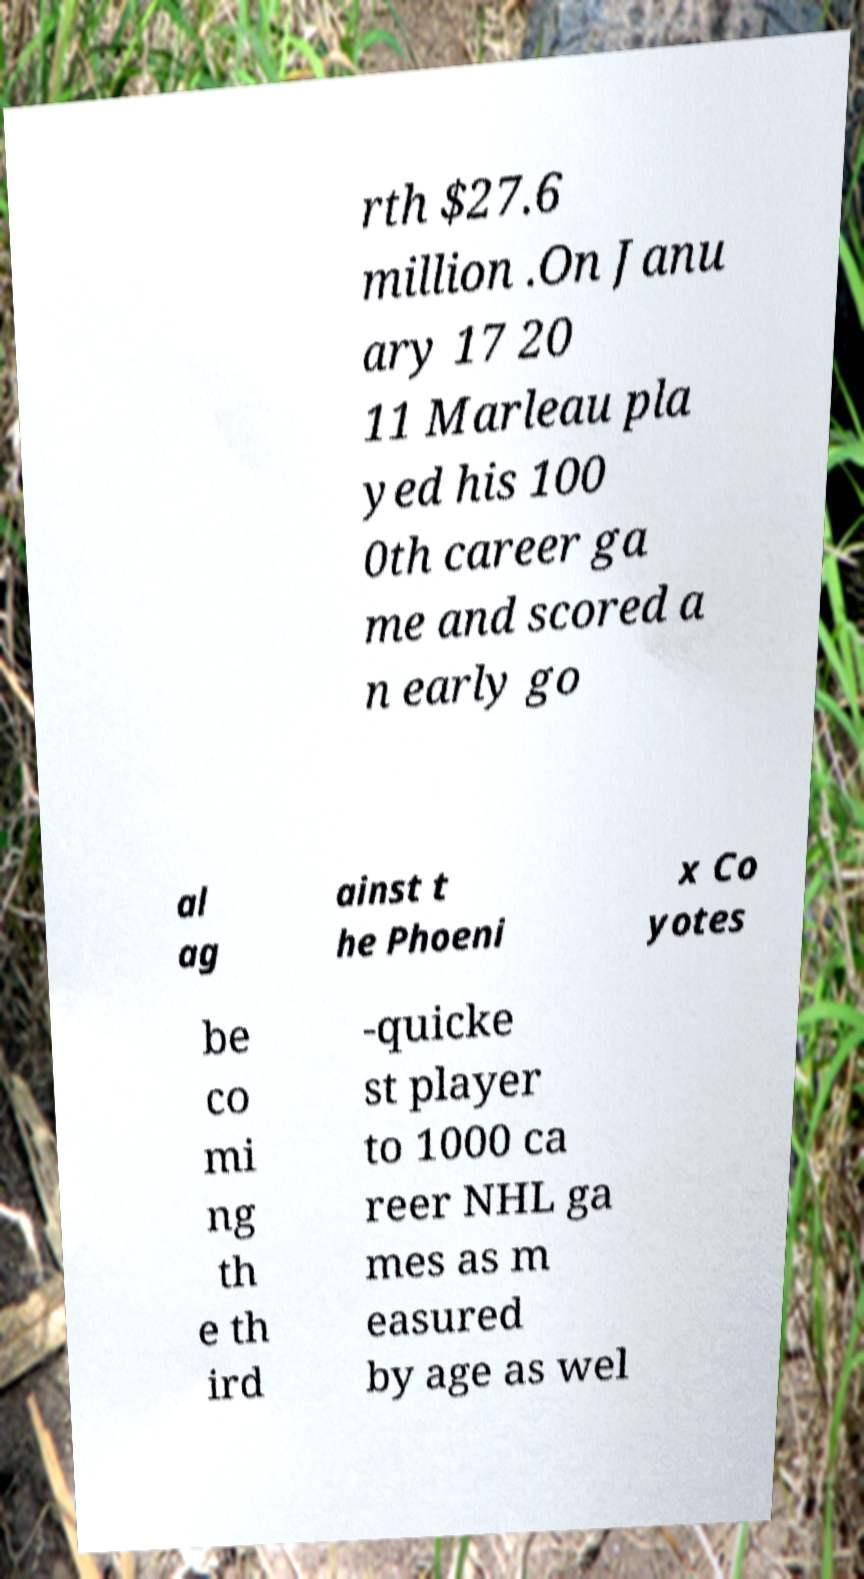What messages or text are displayed in this image? I need them in a readable, typed format. rth $27.6 million .On Janu ary 17 20 11 Marleau pla yed his 100 0th career ga me and scored a n early go al ag ainst t he Phoeni x Co yotes be co mi ng th e th ird -quicke st player to 1000 ca reer NHL ga mes as m easured by age as wel 